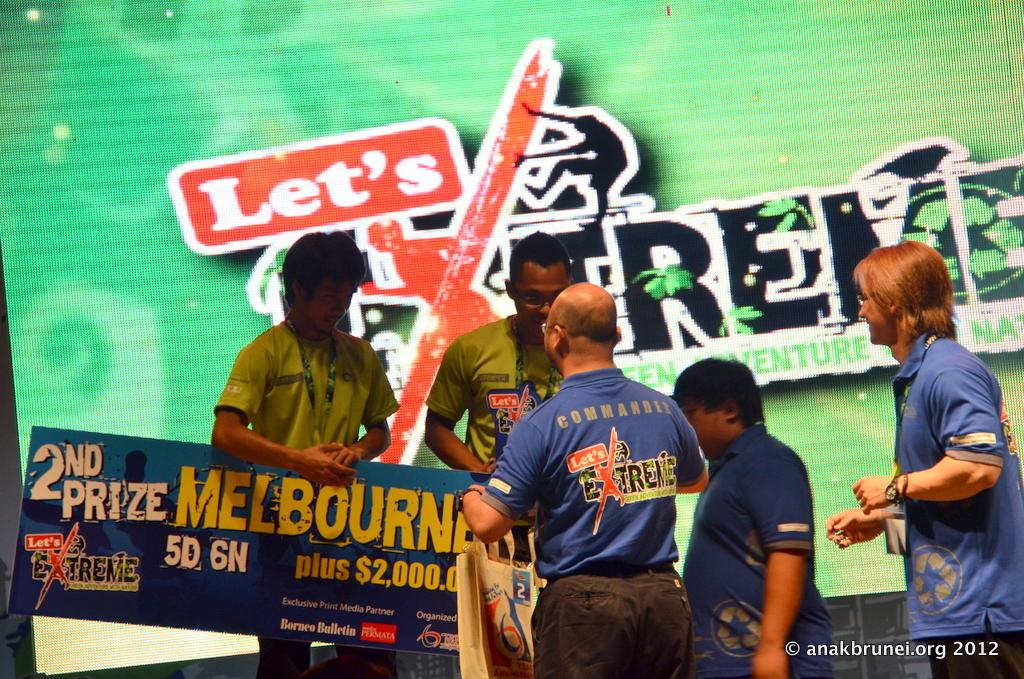What can be seen in the foreground of the image? There are people in the foreground of the image. What are some of the people holding? Some of the people are holding a poster. What is located in the background of the image? There is a screen in the background of the image. Can you describe the text at the bottom side of the image? The text at the bottom side of the image provides additional information or context. Can you tell me how many gates are visible in the image? There are no gates present in the image. Is there any water visible in the image? There is no water visible in the image. 